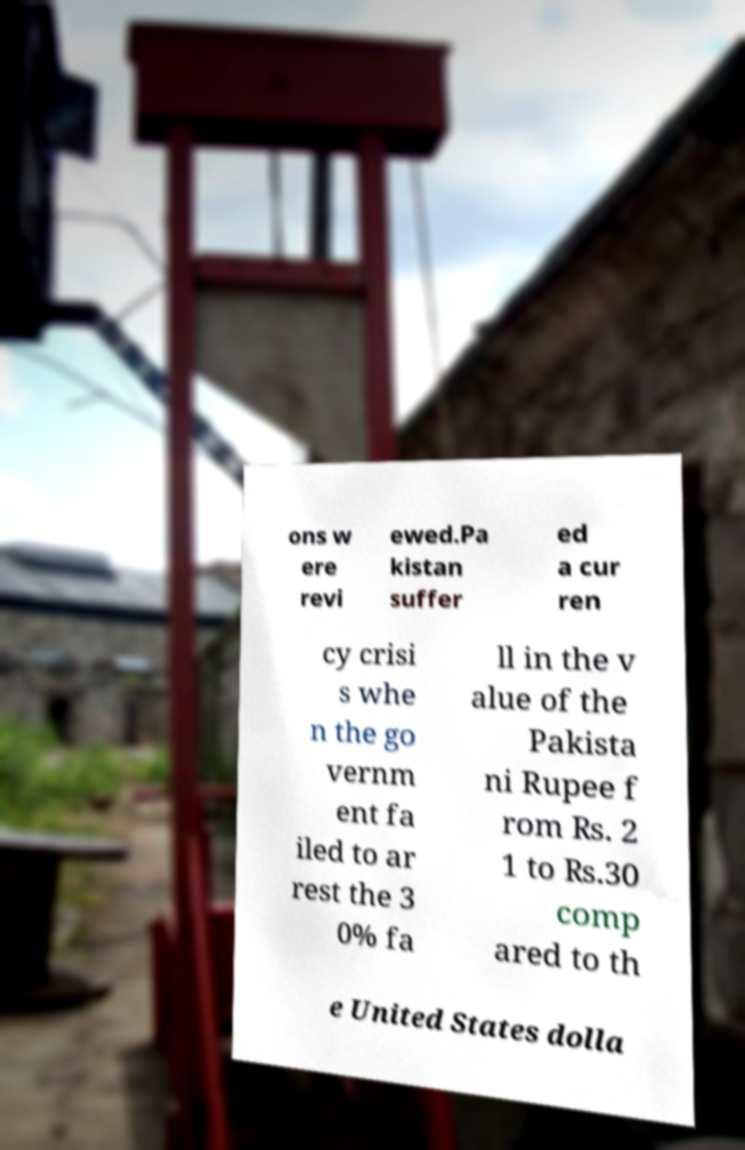Please read and relay the text visible in this image. What does it say? ons w ere revi ewed.Pa kistan suffer ed a cur ren cy crisi s whe n the go vernm ent fa iled to ar rest the 3 0% fa ll in the v alue of the Pakista ni Rupee f rom ₨. 2 1 to ₨.30 comp ared to th e United States dolla 